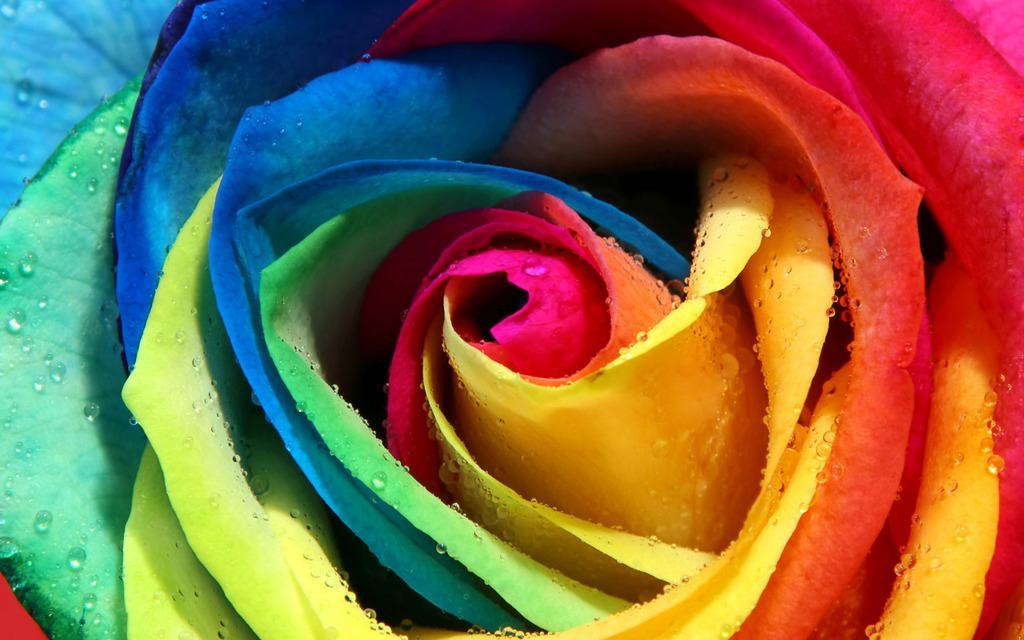Can you describe this image briefly? In this image, we can see a colorful flower. 